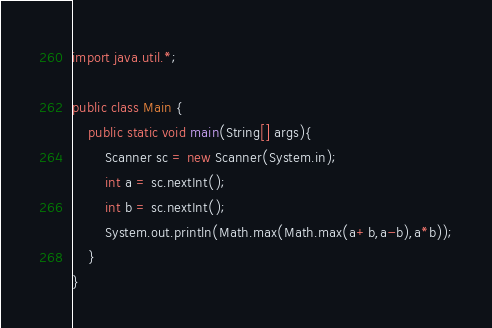<code> <loc_0><loc_0><loc_500><loc_500><_Java_>import java.util.*;

public class Main {
    public static void main(String[] args){
        Scanner sc = new Scanner(System.in);
        int a = sc.nextInt();
        int b = sc.nextInt();
        System.out.println(Math.max(Math.max(a+b,a-b),a*b));
    }
}
</code> 